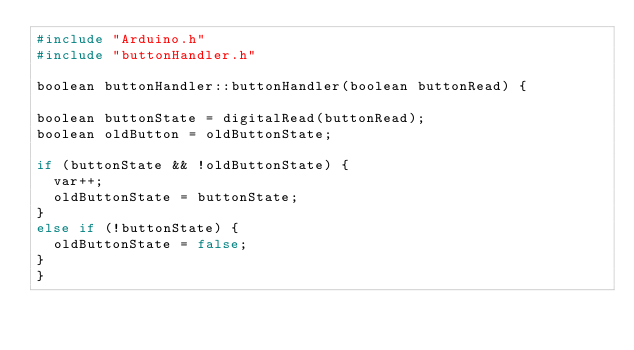<code> <loc_0><loc_0><loc_500><loc_500><_C++_>#include "Arduino.h"
#include "buttonHandler.h"

boolean buttonHandler::buttonHandler(boolean buttonRead) {

boolean buttonState = digitalRead(buttonRead);
boolean oldButton = oldButtonState;

if (buttonState && !oldButtonState) {
  var++;
  oldButtonState = buttonState;
}
else if (!buttonState) {
  oldButtonState = false;
}
}
</code> 